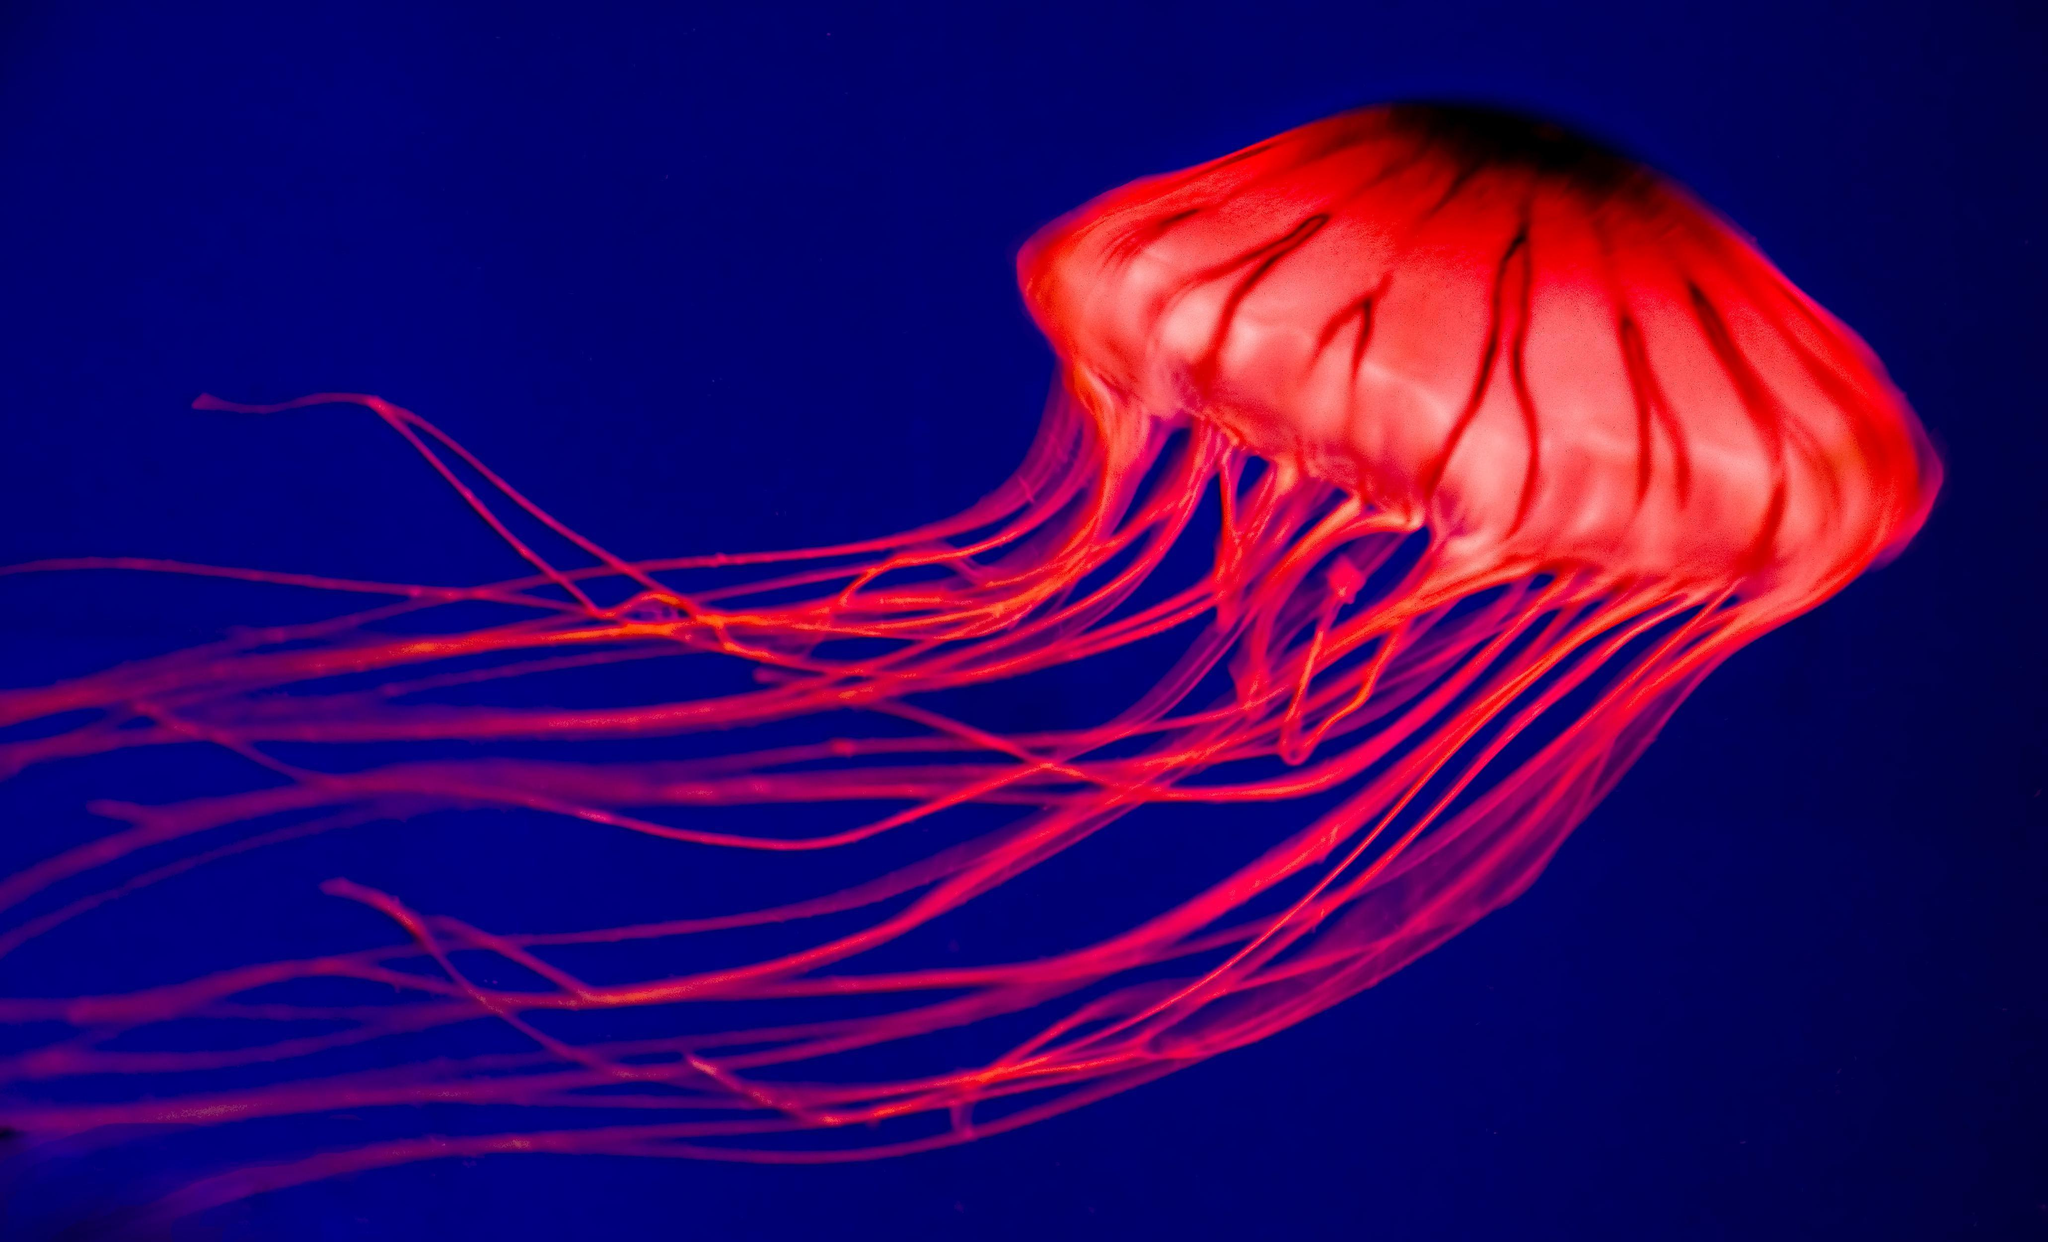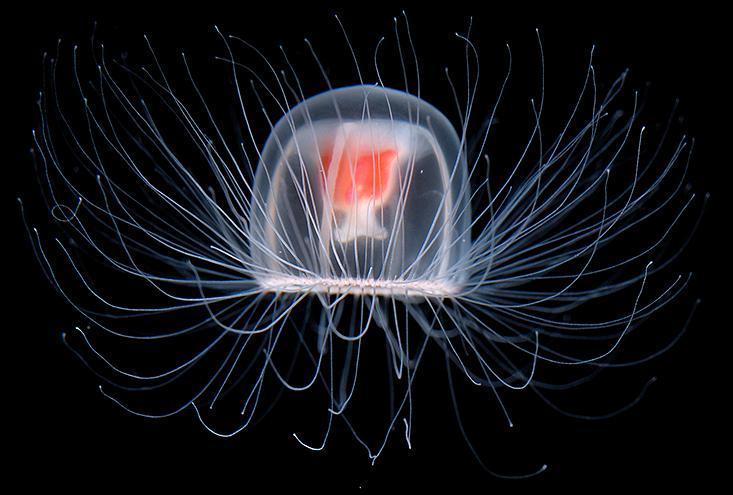The first image is the image on the left, the second image is the image on the right. For the images displayed, is the sentence "a jealyfish is pictured against a black background." factually correct? Answer yes or no. Yes. 